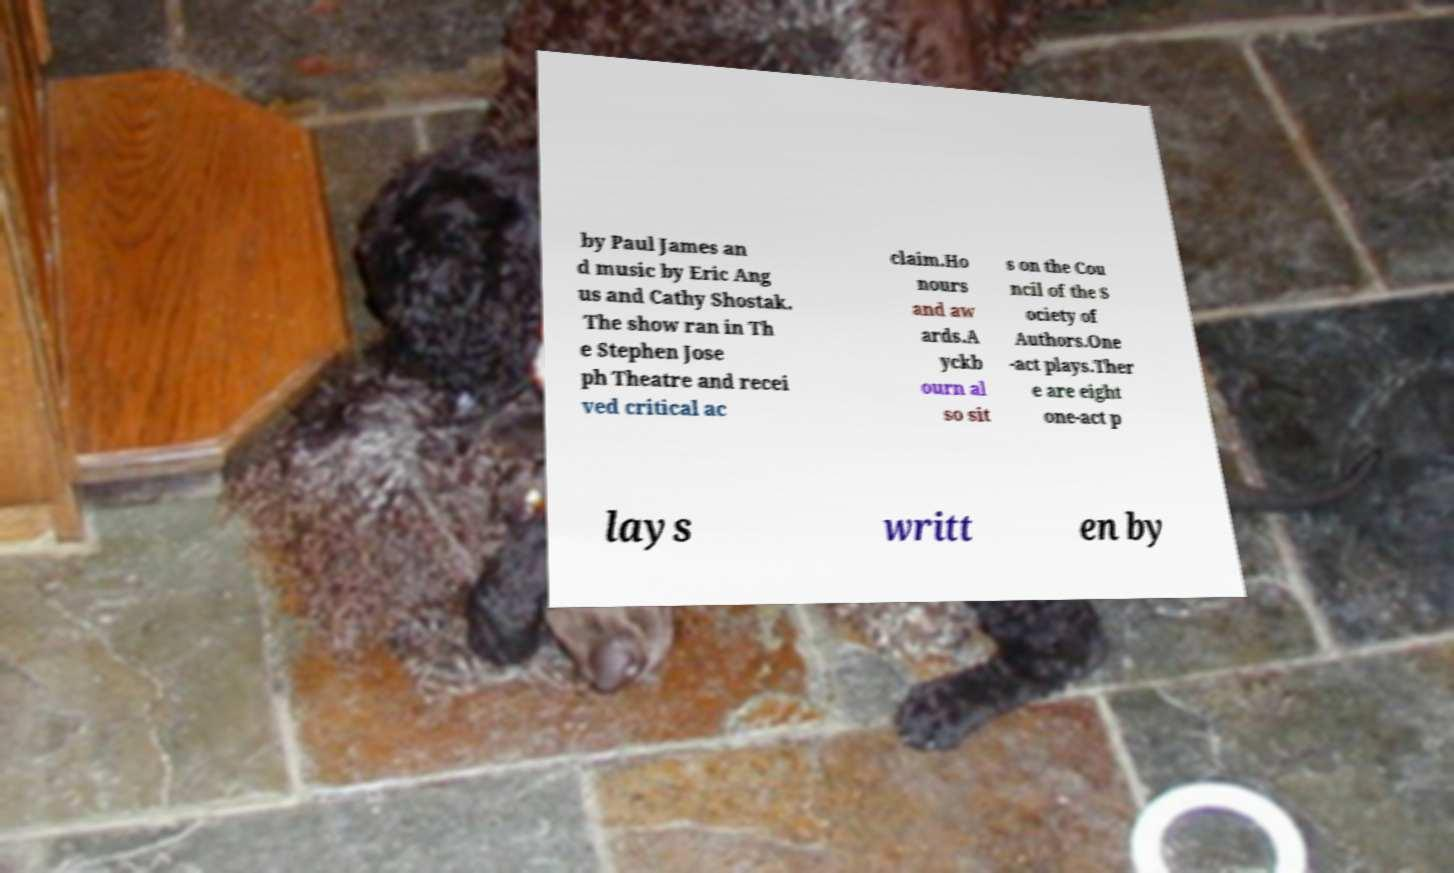Could you assist in decoding the text presented in this image and type it out clearly? by Paul James an d music by Eric Ang us and Cathy Shostak. The show ran in Th e Stephen Jose ph Theatre and recei ved critical ac claim.Ho nours and aw ards.A yckb ourn al so sit s on the Cou ncil of the S ociety of Authors.One -act plays.Ther e are eight one-act p lays writt en by 